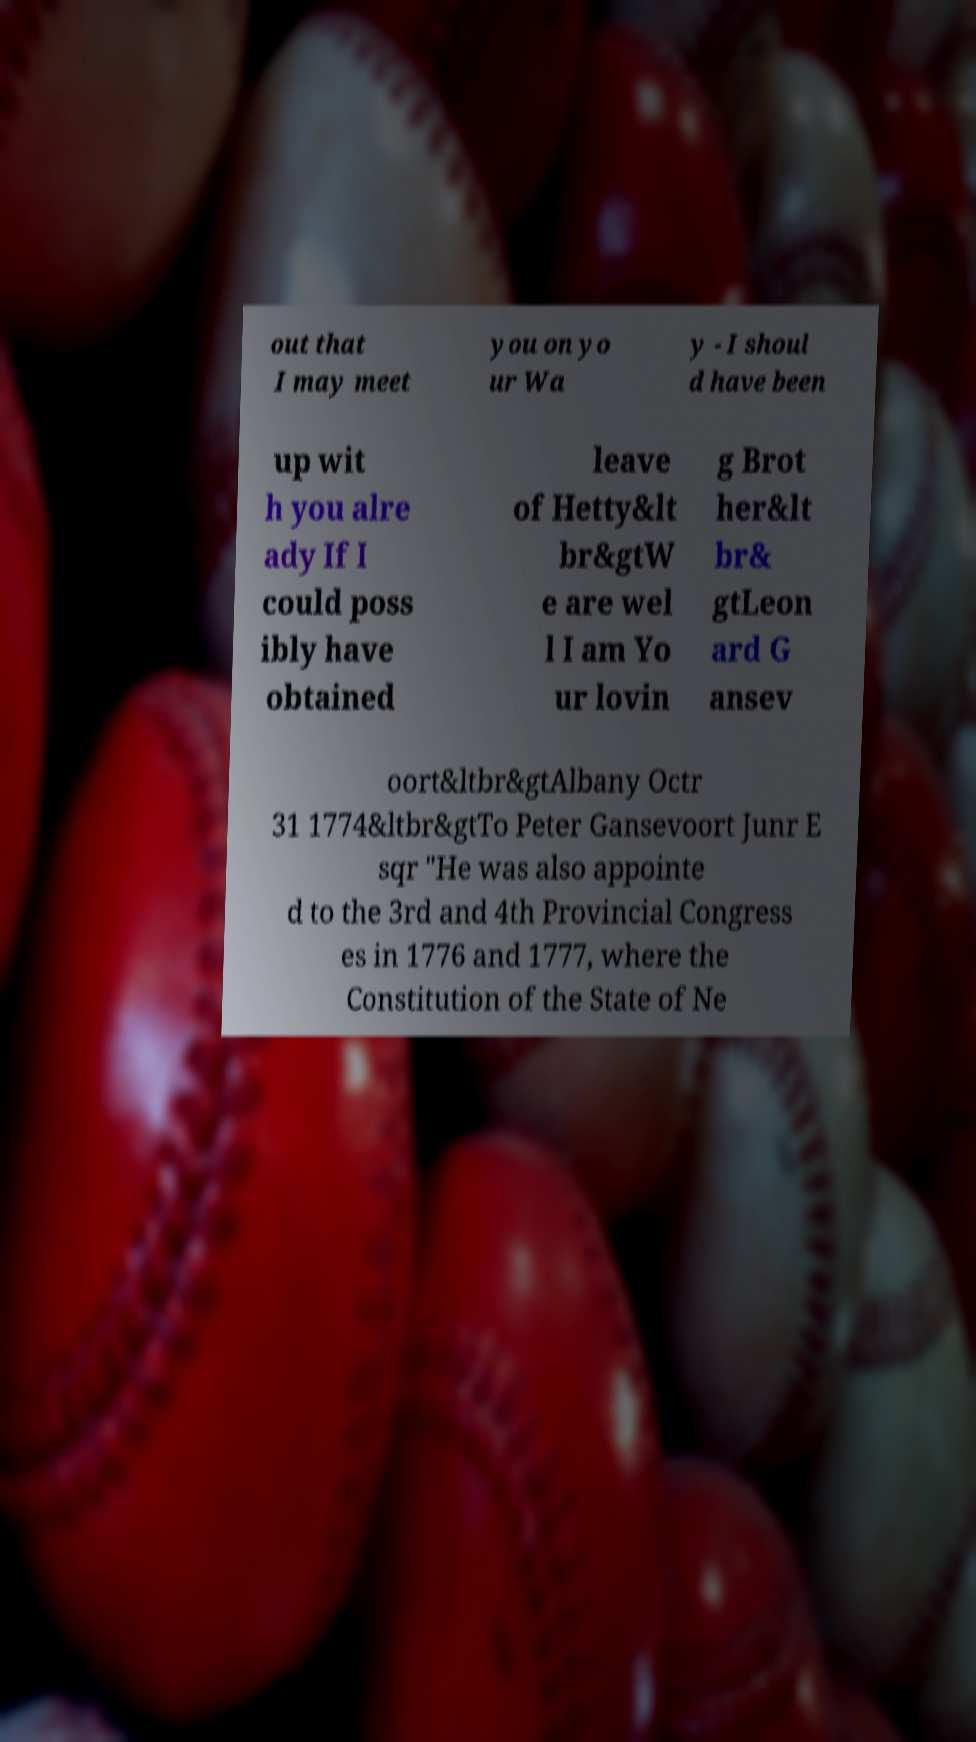Could you assist in decoding the text presented in this image and type it out clearly? out that I may meet you on yo ur Wa y - I shoul d have been up wit h you alre ady If I could poss ibly have obtained leave of Hetty&lt br&gtW e are wel l I am Yo ur lovin g Brot her&lt br& gtLeon ard G ansev oort&ltbr&gtAlbany Octr 31 1774&ltbr&gtTo Peter Gansevoort Junr E sqr "He was also appointe d to the 3rd and 4th Provincial Congress es in 1776 and 1777, where the Constitution of the State of Ne 